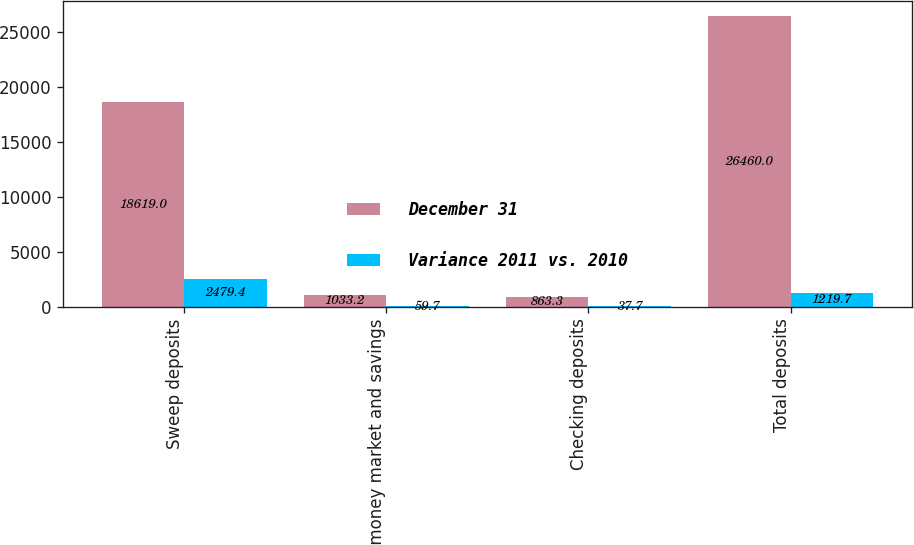Convert chart. <chart><loc_0><loc_0><loc_500><loc_500><stacked_bar_chart><ecel><fcel>Sweep deposits<fcel>Other money market and savings<fcel>Checking deposits<fcel>Total deposits<nl><fcel>December 31<fcel>18619<fcel>1033.2<fcel>863.3<fcel>26460<nl><fcel>Variance 2011 vs. 2010<fcel>2479.4<fcel>59.7<fcel>37.7<fcel>1219.7<nl></chart> 